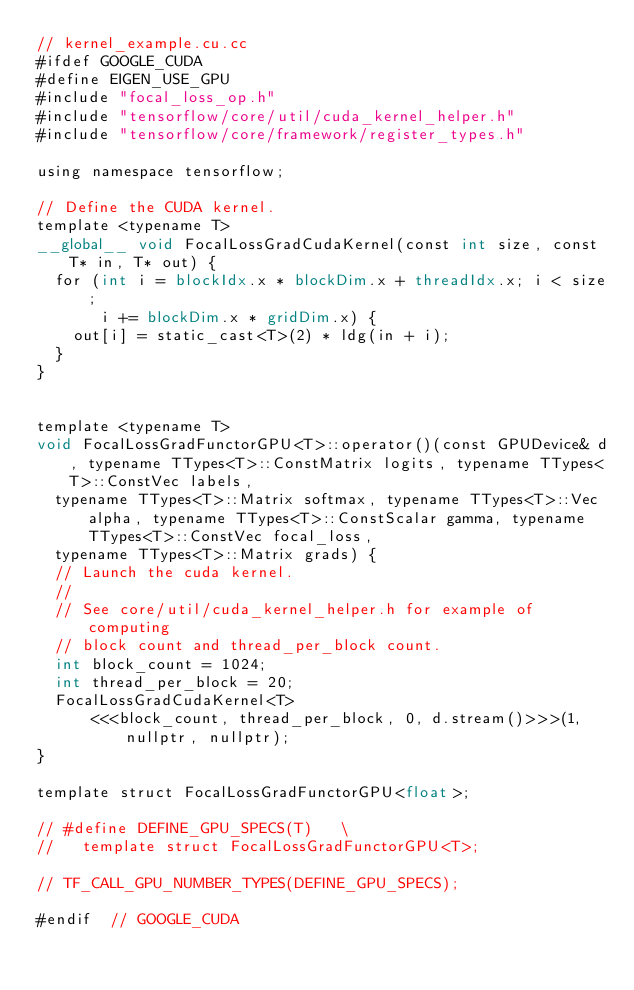<code> <loc_0><loc_0><loc_500><loc_500><_Cuda_>// kernel_example.cu.cc
#ifdef GOOGLE_CUDA
#define EIGEN_USE_GPU
#include "focal_loss_op.h"
#include "tensorflow/core/util/cuda_kernel_helper.h"
#include "tensorflow/core/framework/register_types.h"

using namespace tensorflow;

// Define the CUDA kernel.
template <typename T>
__global__ void FocalLossGradCudaKernel(const int size, const T* in, T* out) {
  for (int i = blockIdx.x * blockDim.x + threadIdx.x; i < size;
       i += blockDim.x * gridDim.x) {
    out[i] = static_cast<T>(2) * ldg(in + i);
  }
}


template <typename T>
void FocalLossGradFunctorGPU<T>::operator()(const GPUDevice& d, typename TTypes<T>::ConstMatrix logits, typename TTypes<T>::ConstVec labels,
  typename TTypes<T>::Matrix softmax, typename TTypes<T>::Vec alpha, typename TTypes<T>::ConstScalar gamma, typename TTypes<T>::ConstVec focal_loss,
  typename TTypes<T>::Matrix grads) {
  // Launch the cuda kernel.
  //
  // See core/util/cuda_kernel_helper.h for example of computing
  // block count and thread_per_block count.
  int block_count = 1024;
  int thread_per_block = 20;
  FocalLossGradCudaKernel<T>
      <<<block_count, thread_per_block, 0, d.stream()>>>(1, nullptr, nullptr);
}

template struct FocalLossGradFunctorGPU<float>;

// #define DEFINE_GPU_SPECS(T)   \
//   template struct FocalLossGradFunctorGPU<T>;

// TF_CALL_GPU_NUMBER_TYPES(DEFINE_GPU_SPECS);

#endif  // GOOGLE_CUDA
</code> 